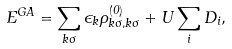Convert formula to latex. <formula><loc_0><loc_0><loc_500><loc_500>E ^ { G A } = \sum _ { k \sigma } \epsilon _ { k } \rho ^ { ( 0 ) } _ { k \sigma , k \sigma } + U \sum _ { i } D _ { i } ,</formula> 